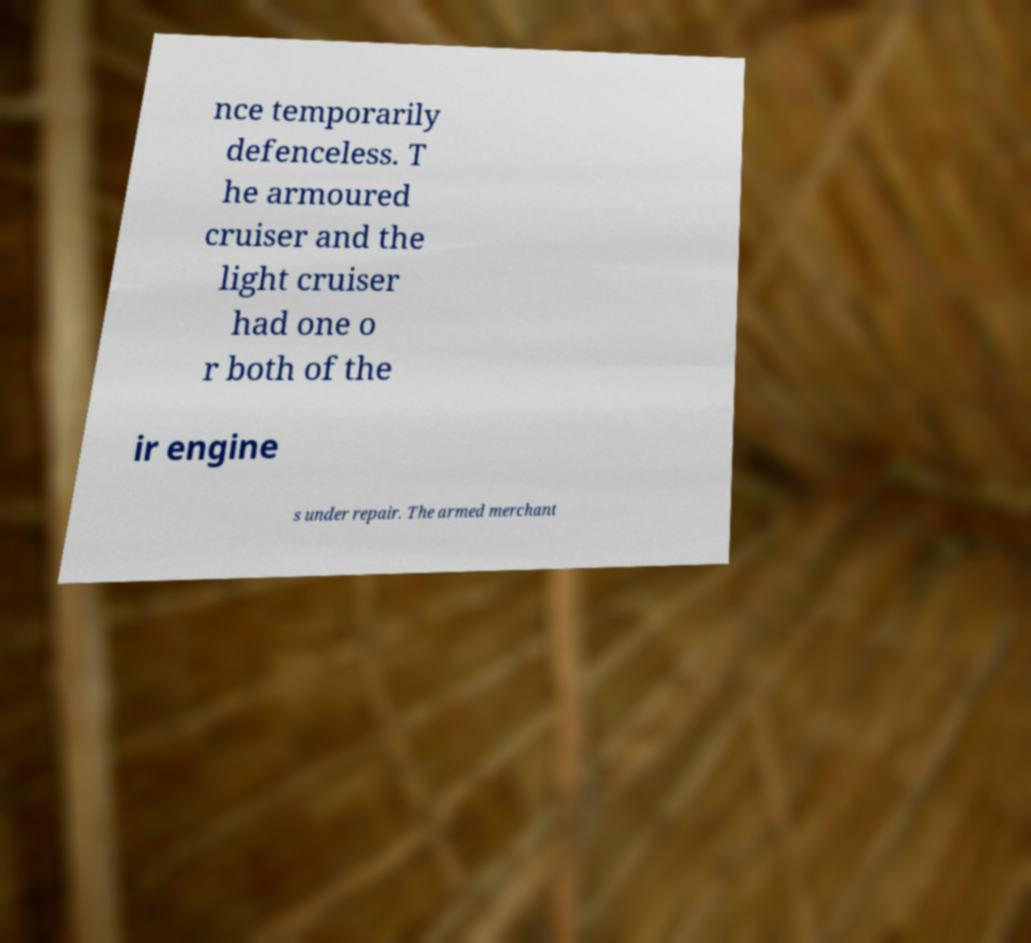Please identify and transcribe the text found in this image. nce temporarily defenceless. T he armoured cruiser and the light cruiser had one o r both of the ir engine s under repair. The armed merchant 